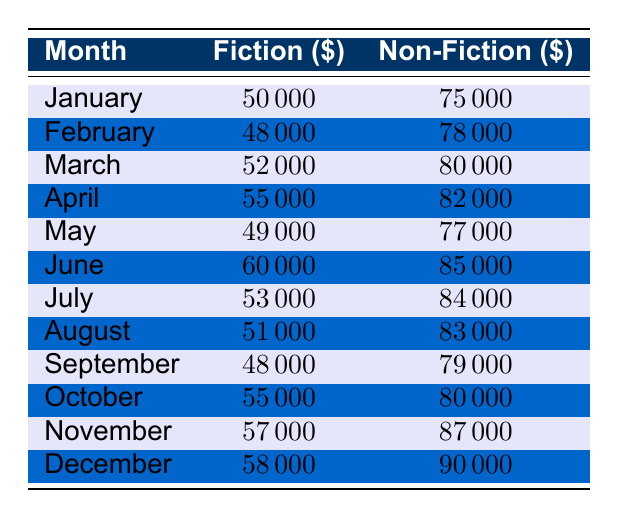What was the total revenue for fiction in March and April? In March, the revenue for fiction is 52000, and in April, it is 55000. Summing these two values gives us 52000 + 55000 = 107000.
Answer: 107000 What was the highest revenue for non-fiction in a month? By scanning the non-fiction column, December shows the highest revenue at 90000.
Answer: 90000 Was the revenue for fiction greater than or equal to 50000 in October? In October, the fiction revenue is 55000, which is greater than 50000. Therefore, the statement is true.
Answer: Yes What is the average revenue for non-fiction across all months? To compute the average, first sum all non-fiction revenues: (75000 + 78000 + 80000 + 82000 + 77000 + 85000 + 84000 + 83000 + 79000 + 80000 + 87000 + 90000) = 1008000. There are 12 months, so the average is 1008000 / 12 = 84000.
Answer: 84000 In how many months did fiction revenue exceed 50000? Reviewing the fiction revenue, we note the months: January (50000), March (52000), April (55000), June (60000), July (53000), October (55000), November (57000), and December (58000) exceed 50000. Counting these gives us 8 months.
Answer: 8 What was the total revenue for non-fiction in the first half of the year? The months from January to June for non-fiction are: 75000, 78000, 80000, 82000, 77000, and 85000. Summing these gives: 75000 + 78000 + 80000 + 82000 + 77000 + 85000 = 395000.
Answer: 395000 Did fiction revenue decline from February to March? In February, the fiction revenue is 48000, and in March, it rises to 52000. Thus, there is an increase, so the statement is false.
Answer: No Which month had the smallest fiction revenue? Looking at the values in the fiction column, February has the smallest revenue at 48000.
Answer: 48000 